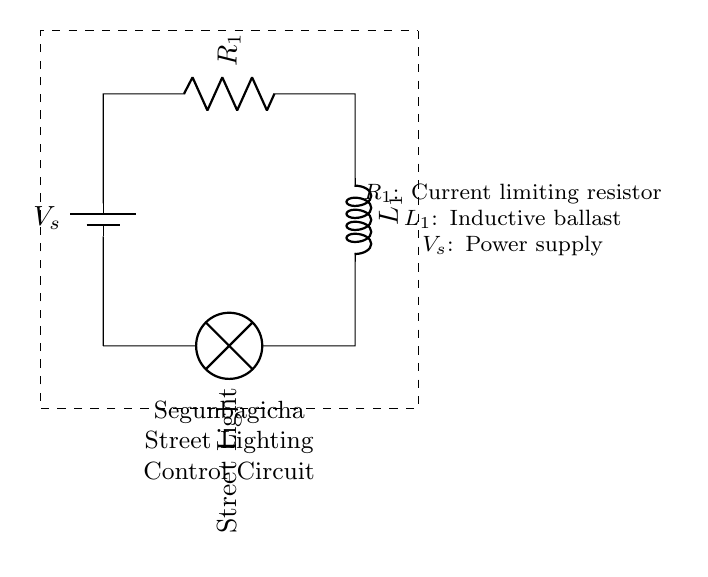What type of circuit is represented? This circuit is a Resistor-Inductor circuit designed for controlling street lighting. The presence of both a resistor and an inductor confirms its classification.
Answer: Resistor-Inductor What is the function of R1 in the circuit? R1 is a current limiting resistor which regulates the amount of current flowing through the circuit to protect the street light.
Answer: Current limiting resistor What does L1 represent in this circuit? L1 is an inductive ballast that helps to stabilize the current and voltage in the circuit, thereby enhancing the performance of the street light.
Answer: Inductive ballast What is the role of the power supply (Vs)? The power supply (Vs) provides the necessary voltage to power the entire circuit, ensuring that the street light operates correctly.
Answer: Power supply How are the components connected in this circuit? The components are connected in series: the power supply feeds into the resistor, which then connects to the inductor, and finally to the street light.
Answer: Series connection Why might we use an inductor in street lighting? An inductor helps smooth out fluctuations in the current, providing more stable lighting performance and reducing flicker in the street light.
Answer: Stability of current What happens if R1 is too high in resistance? If R1 has a high resistance, it could restrict too much current, potentially making the street light dim or not illuminate at all.
Answer: Dim or no illumination 